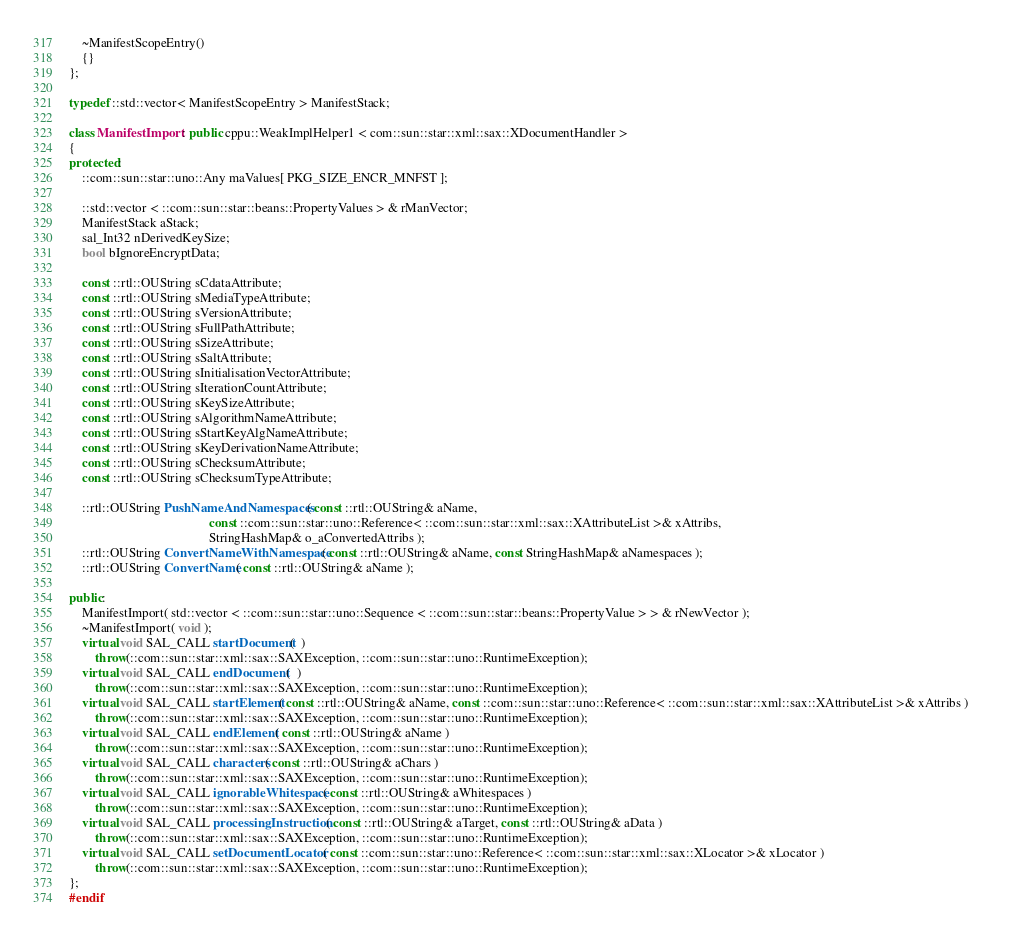<code> <loc_0><loc_0><loc_500><loc_500><_C++_>    ~ManifestScopeEntry()
    {}
};

typedef ::std::vector< ManifestScopeEntry > ManifestStack;

class ManifestImport : public cppu::WeakImplHelper1 < com::sun::star::xml::sax::XDocumentHandler >
{
protected:
	::com::sun::star::uno::Any maValues[ PKG_SIZE_ENCR_MNFST ];

	::std::vector < ::com::sun::star::beans::PropertyValues > & rManVector;
	ManifestStack aStack;
    sal_Int32 nDerivedKeySize;
	bool bIgnoreEncryptData;

	const ::rtl::OUString sCdataAttribute;
	const ::rtl::OUString sMediaTypeAttribute;
	const ::rtl::OUString sVersionAttribute;
	const ::rtl::OUString sFullPathAttribute;
	const ::rtl::OUString sSizeAttribute;
	const ::rtl::OUString sSaltAttribute;
	const ::rtl::OUString sInitialisationVectorAttribute;
	const ::rtl::OUString sIterationCountAttribute;
	const ::rtl::OUString sKeySizeAttribute;
	const ::rtl::OUString sAlgorithmNameAttribute;
	const ::rtl::OUString sStartKeyAlgNameAttribute;
	const ::rtl::OUString sKeyDerivationNameAttribute;
	const ::rtl::OUString sChecksumAttribute;
	const ::rtl::OUString sChecksumTypeAttribute;

    ::rtl::OUString PushNameAndNamespaces( const ::rtl::OUString& aName,
                                           const ::com::sun::star::uno::Reference< ::com::sun::star::xml::sax::XAttributeList >& xAttribs,
                                           StringHashMap& o_aConvertedAttribs );
    ::rtl::OUString ConvertNameWithNamespace( const ::rtl::OUString& aName, const StringHashMap& aNamespaces );
    ::rtl::OUString ConvertName( const ::rtl::OUString& aName );

public:
	ManifestImport( std::vector < ::com::sun::star::uno::Sequence < ::com::sun::star::beans::PropertyValue > > & rNewVector );
	~ManifestImport( void );
    virtual void SAL_CALL startDocument(  ) 	
		throw(::com::sun::star::xml::sax::SAXException, ::com::sun::star::uno::RuntimeException);
    virtual void SAL_CALL endDocument(  ) 	
		throw(::com::sun::star::xml::sax::SAXException, ::com::sun::star::uno::RuntimeException);
    virtual void SAL_CALL startElement( const ::rtl::OUString& aName, const ::com::sun::star::uno::Reference< ::com::sun::star::xml::sax::XAttributeList >& xAttribs ) 	
		throw(::com::sun::star::xml::sax::SAXException, ::com::sun::star::uno::RuntimeException);
    virtual void SAL_CALL endElement( const ::rtl::OUString& aName ) 	
		throw(::com::sun::star::xml::sax::SAXException, ::com::sun::star::uno::RuntimeException);
    virtual void SAL_CALL characters( const ::rtl::OUString& aChars ) 	
		throw(::com::sun::star::xml::sax::SAXException, ::com::sun::star::uno::RuntimeException);
    virtual void SAL_CALL ignorableWhitespace( const ::rtl::OUString& aWhitespaces ) 	
		throw(::com::sun::star::xml::sax::SAXException, ::com::sun::star::uno::RuntimeException);
    virtual void SAL_CALL processingInstruction( const ::rtl::OUString& aTarget, const ::rtl::OUString& aData ) 	
		throw(::com::sun::star::xml::sax::SAXException, ::com::sun::star::uno::RuntimeException);
    virtual void SAL_CALL setDocumentLocator( const ::com::sun::star::uno::Reference< ::com::sun::star::xml::sax::XLocator >& xLocator ) 	
		throw(::com::sun::star::xml::sax::SAXException, ::com::sun::star::uno::RuntimeException);
};
#endif
</code> 